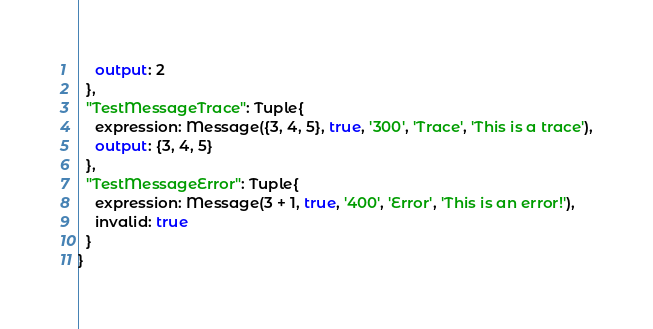Convert code to text. <code><loc_0><loc_0><loc_500><loc_500><_SQL_>    output: 2
  },
  "TestMessageTrace": Tuple{
    expression: Message({3, 4, 5}, true, '300', 'Trace', 'This is a trace'),
    output: {3, 4, 5}
  },
  "TestMessageError": Tuple{
    expression: Message(3 + 1, true, '400', 'Error', 'This is an error!'),
    invalid: true
  }
}
</code> 